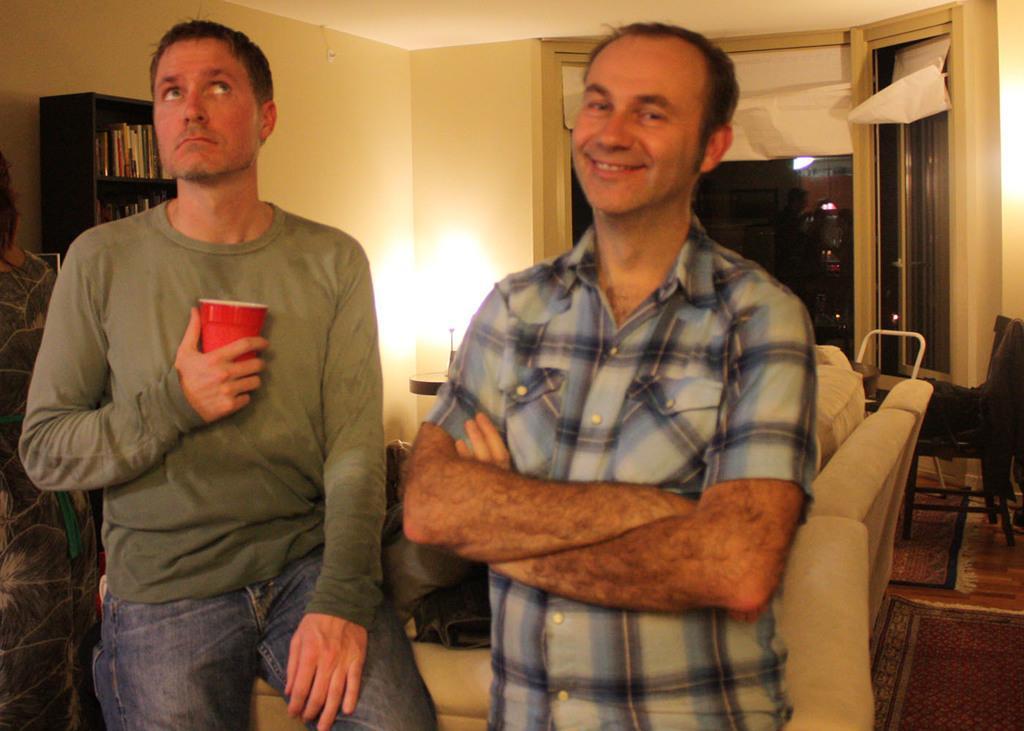In one or two sentences, can you explain what this image depicts? In this image, we can see people and one of them is holding a cup. In the background, we can see a sofa and there is a cloth on the chair and we can see books in the rack and there are some other objects, a light and a wall. At the bottom, there are carpets on the floor. 